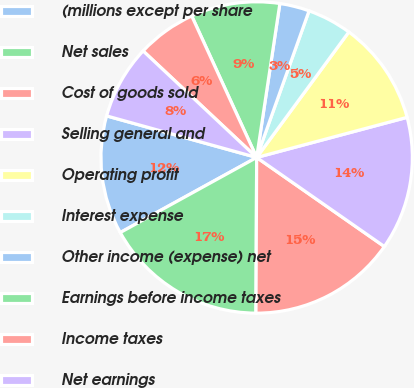Convert chart. <chart><loc_0><loc_0><loc_500><loc_500><pie_chart><fcel>(millions except per share<fcel>Net sales<fcel>Cost of goods sold<fcel>Selling general and<fcel>Operating profit<fcel>Interest expense<fcel>Other income (expense) net<fcel>Earnings before income taxes<fcel>Income taxes<fcel>Net earnings<nl><fcel>12.31%<fcel>16.92%<fcel>15.38%<fcel>13.84%<fcel>10.77%<fcel>4.62%<fcel>3.08%<fcel>9.23%<fcel>6.16%<fcel>7.69%<nl></chart> 